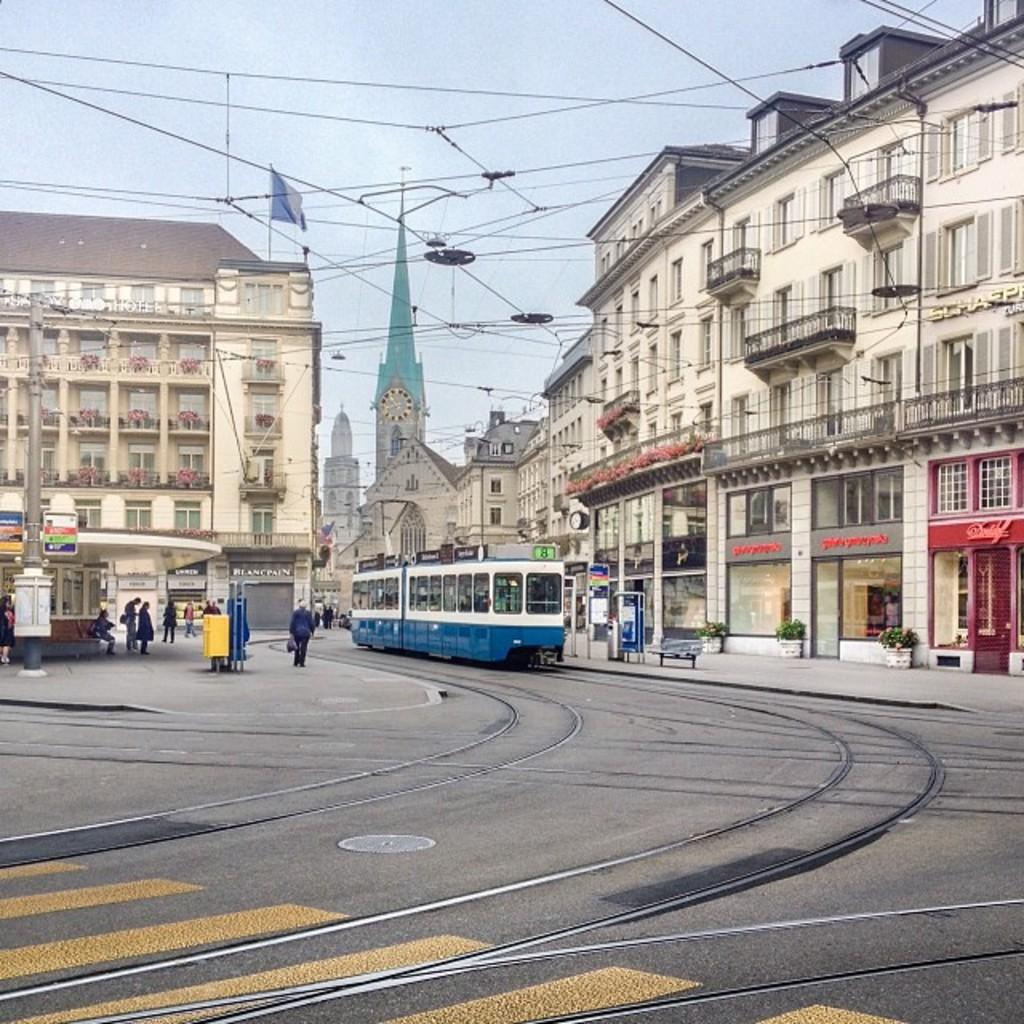What is the main subject of the image? The main subject of the image is a train on the track. What else can be seen in the image besides the train? There are buildings and wires in the image. What is visible at the top of the image? The sky is visible at the top of the image. Can you see any goldfish swimming in the image? There are no goldfish present in the image. What type of rifle is being used by the friends in the image? There are no friends or rifles present in the image. 